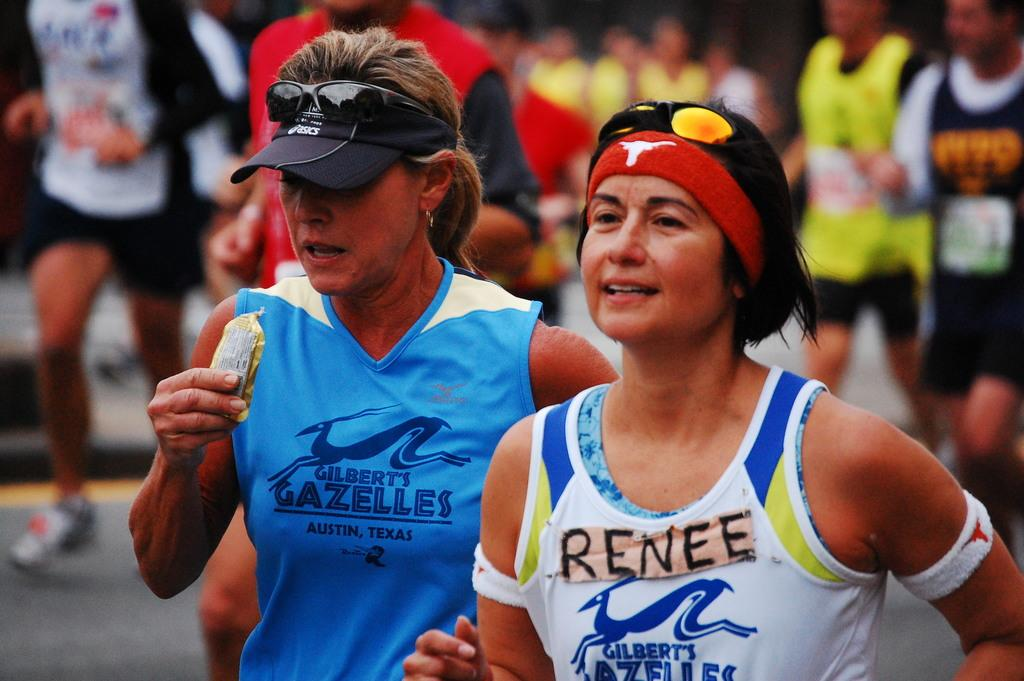<image>
Share a concise interpretation of the image provided. Renee runs with other runners in an event called Gilbert's Gazelles 